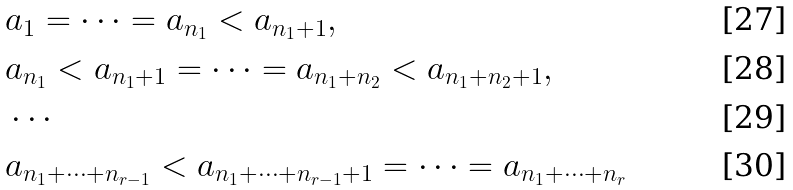<formula> <loc_0><loc_0><loc_500><loc_500>& a _ { 1 } = \cdots = a _ { n _ { 1 } } < a _ { n _ { 1 } + 1 } , \\ & a _ { n _ { 1 } } < a _ { n _ { 1 } + 1 } = \cdots = a _ { n _ { 1 } + n _ { 2 } } < a _ { n _ { 1 } + n _ { 2 } + 1 } , \\ & \cdots \\ & a _ { n _ { 1 } + \cdots + n _ { r - 1 } } < a _ { n _ { 1 } + \cdots + n _ { r - 1 } + 1 } = \cdots = a _ { n _ { 1 } + \cdots + n _ { r } }</formula> 